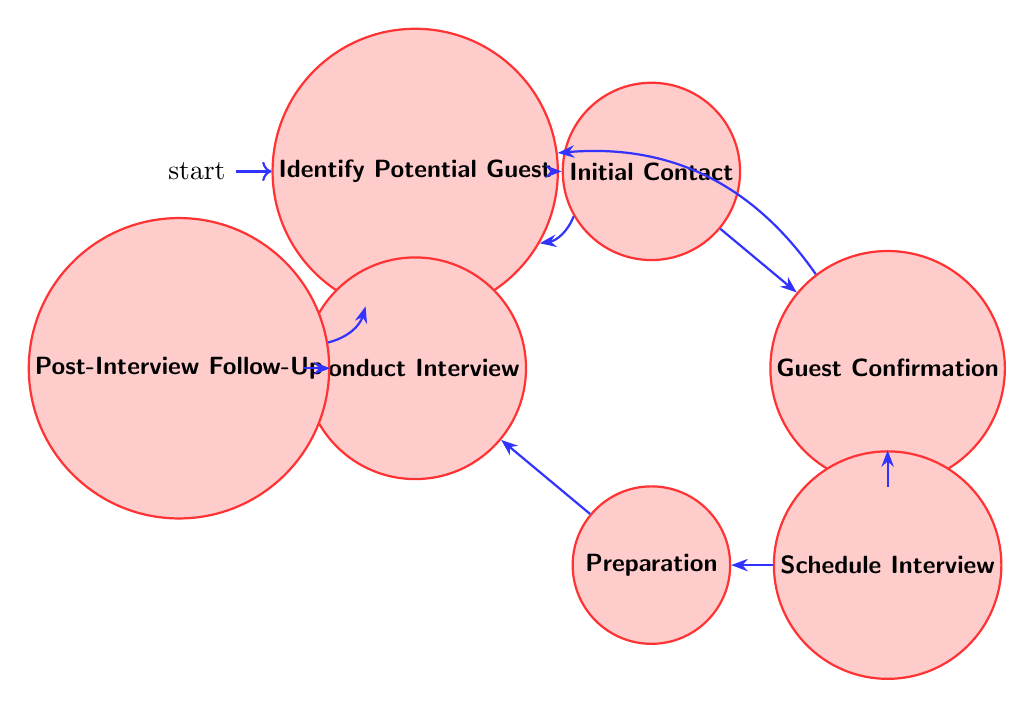What is the first state of the diagram? The diagram begins with the "Identify Potential Guest" state, which is marked as the initial state. This can be seen visually as it is the starting point of the directed transitions.
Answer: Identify Potential Guest How many nodes are present in the diagram? Counting the distinct states listed in the diagram, there are a total of seven states. The states are: "Identify Potential Guest," "Initial Contact," "Guest Confirmation," "Schedule Interview," "Preparation," "Conduct Interview," and "Post-Interview Follow-Up."
Answer: 7 Which state transitions to "Schedule Interview"? From the diagram, the only state that transitions into "Schedule Interview" is "Guest Confirmation." This is indicated by the directed edge going from "Guest Confirmation" to "Schedule Interview."
Answer: Guest Confirmation What actions are associated with the "Preparation" state? The actions listed for the "Preparation" state include "Prepare questions" and "Research guest's background and recent activities." Looking at the actions associated with this state provides a clear understanding of its purpose.
Answer: Prepare questions, Research guest's background and recent activities If the interview is conducted, which state follows next? After the "Conduct Interview" state, the diagram indicates that the next state is "Post-Interview Follow-Up," connected by a directed edge. This shows the sequential nature of the process.
Answer: Post-Interview Follow-Up What is the purpose of the "Initial Contact" state? The "Initial Contact" state involves actions such as "Reach out to guest’s public relations team" and "Send initial invitation via email or phone." These actions clarify the purpose of this state as initiating communication with potential guests.
Answer: Reach out to guest’s public relations team, Send initial invitation via email or phone Which two states allow a return to "Identify Potential Guest"? Both the "Initial Contact" and "Guest Confirmation" states have directed edges back to "Identify Potential Guest." This indicates that if no confirmation or a suitable guest is found, the process can revert back to identifying new potential guests.
Answer: Initial Contact, Guest Confirmation What is the last state in the process? The last state in the process is "Post-Interview Follow-Up." It is clear from the flow of the diagram that "Post-Interview Follow-Up" concludes this finite state machine process.
Answer: Post-Interview Follow-Up 